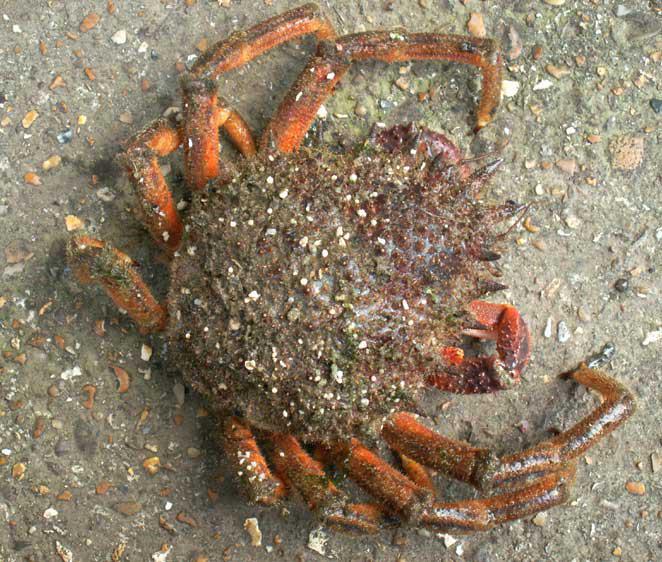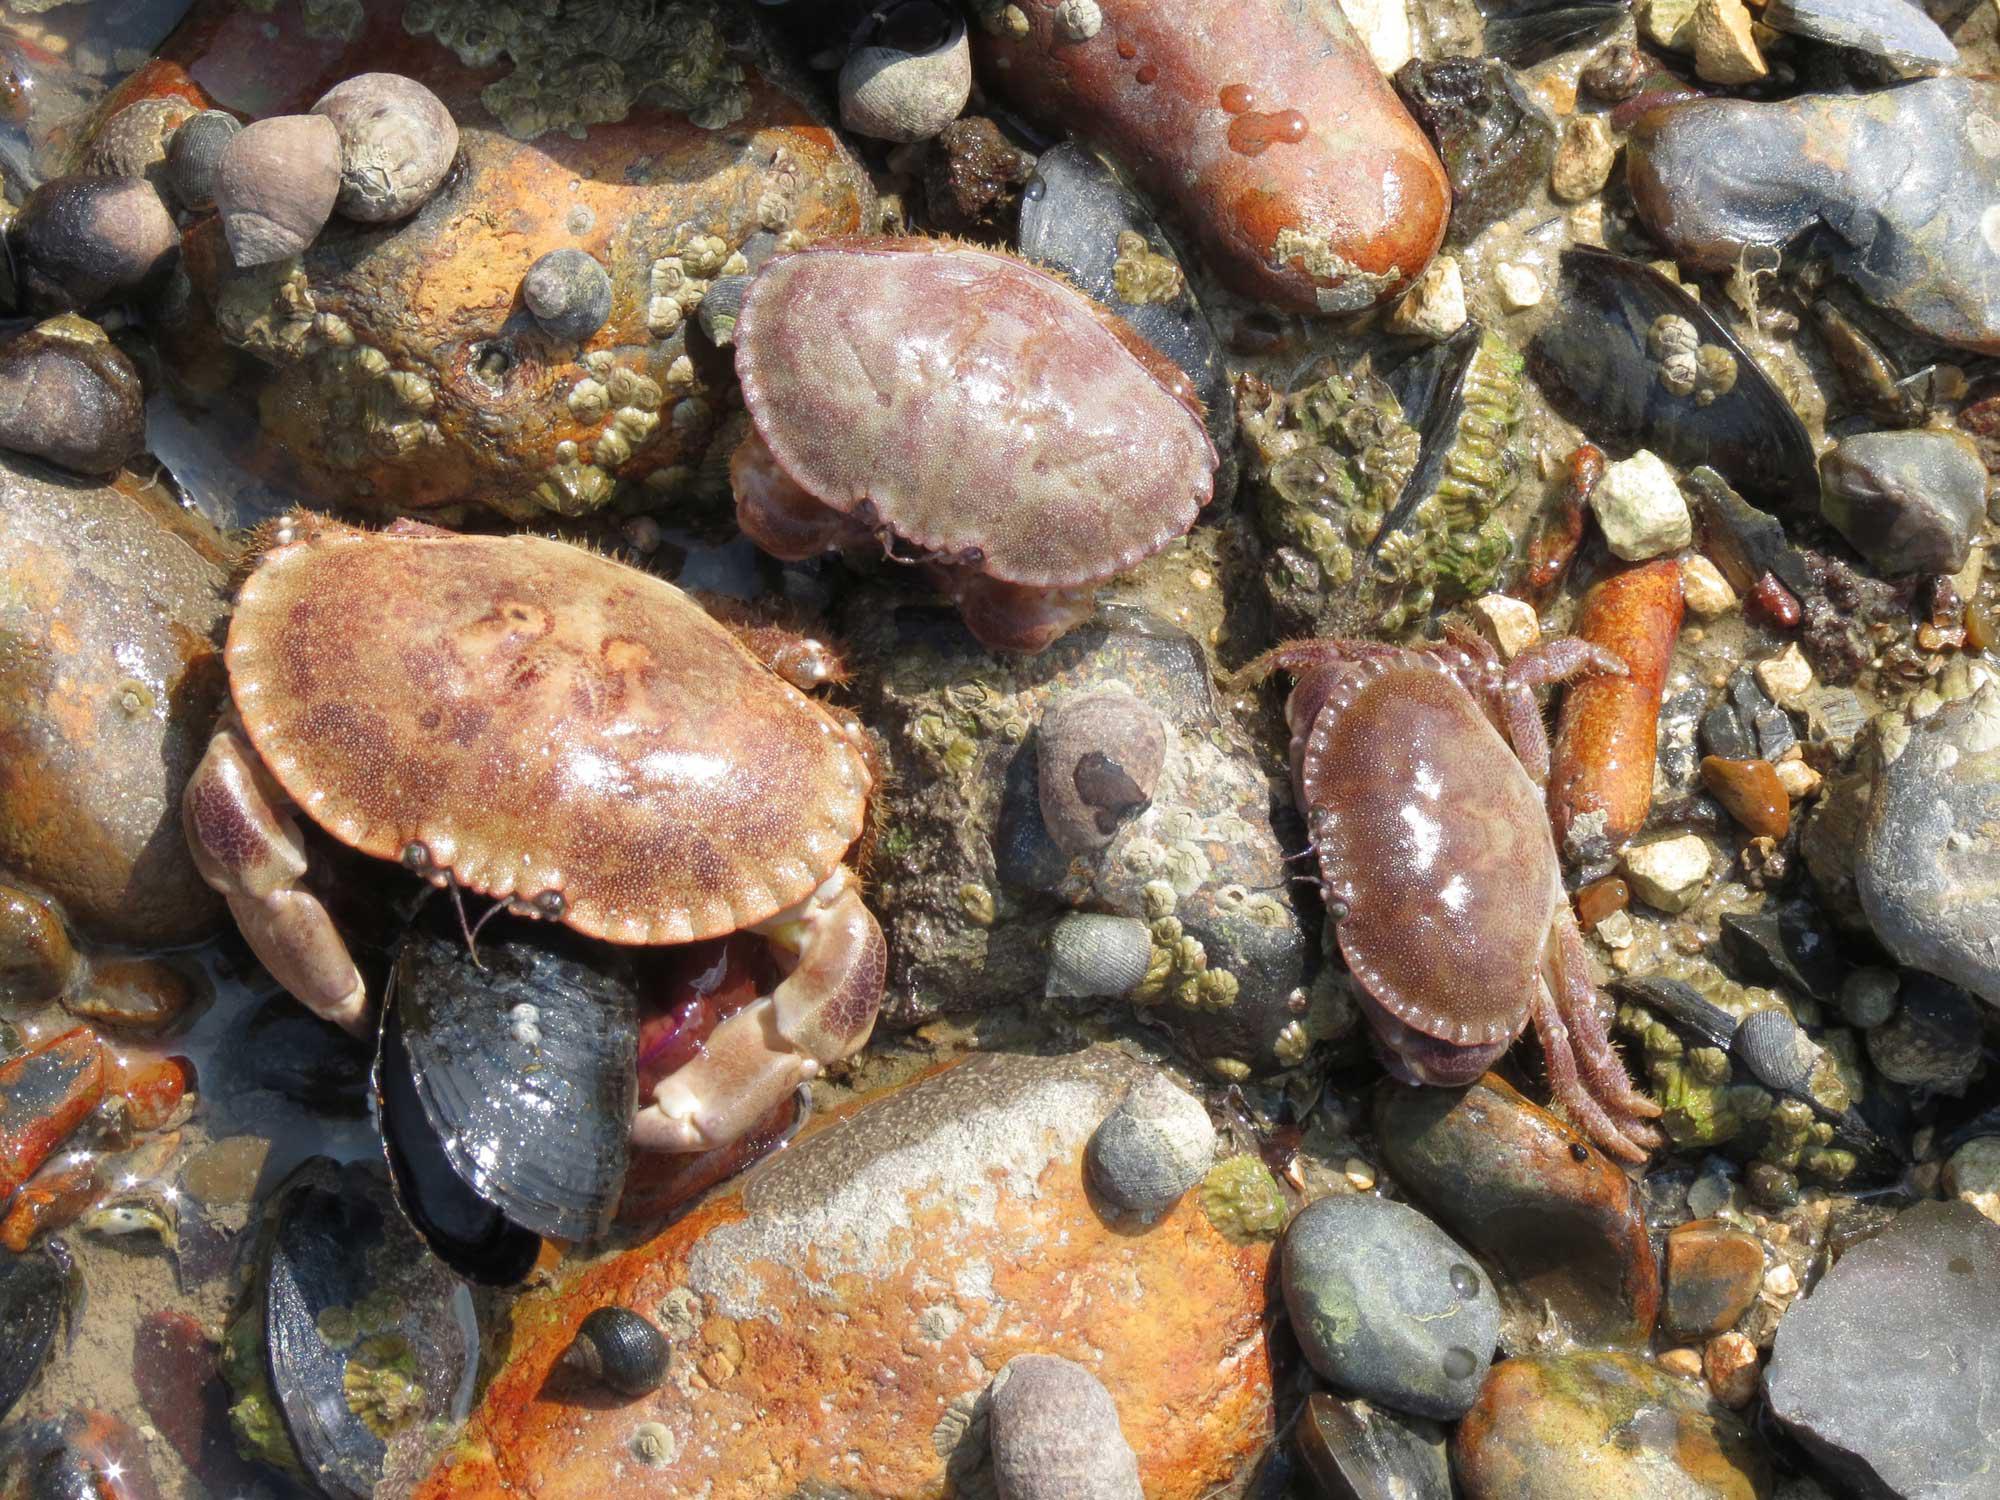The first image is the image on the left, the second image is the image on the right. Given the left and right images, does the statement "There are exactly two crabs." hold true? Answer yes or no. No. The first image is the image on the left, the second image is the image on the right. Examine the images to the left and right. Is the description "An image shows a ruler displayed horizontally under a crab facing forward." accurate? Answer yes or no. No. 